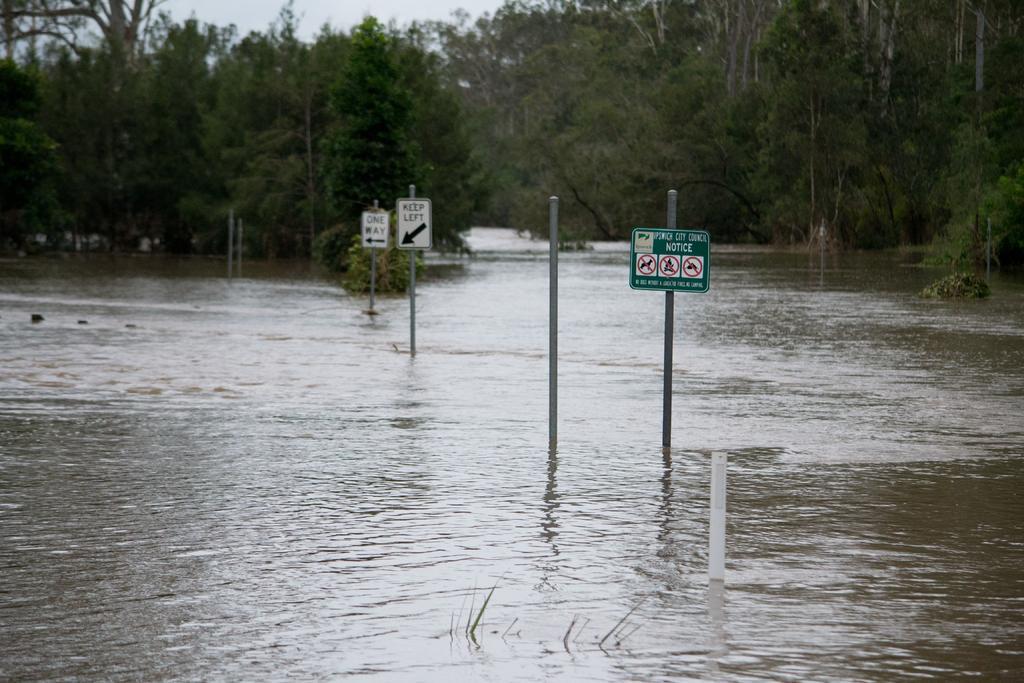Can you describe this image briefly? In this image there are poles and there are directional boards in the water. In the background of the image there are trees and sky. 